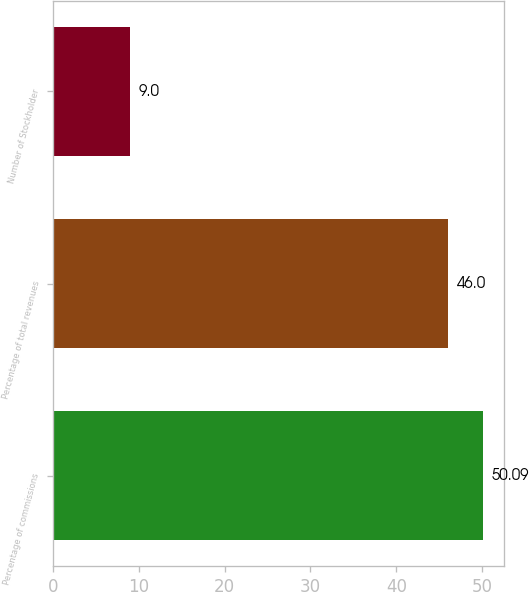<chart> <loc_0><loc_0><loc_500><loc_500><bar_chart><fcel>Percentage of commissions<fcel>Percentage of total revenues<fcel>Number of Stockholder<nl><fcel>50.09<fcel>46<fcel>9<nl></chart> 